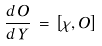Convert formula to latex. <formula><loc_0><loc_0><loc_500><loc_500>\frac { d \, \hat { O } } { d \, Y } \, = \, \left [ \chi , \hat { O } \right ]</formula> 